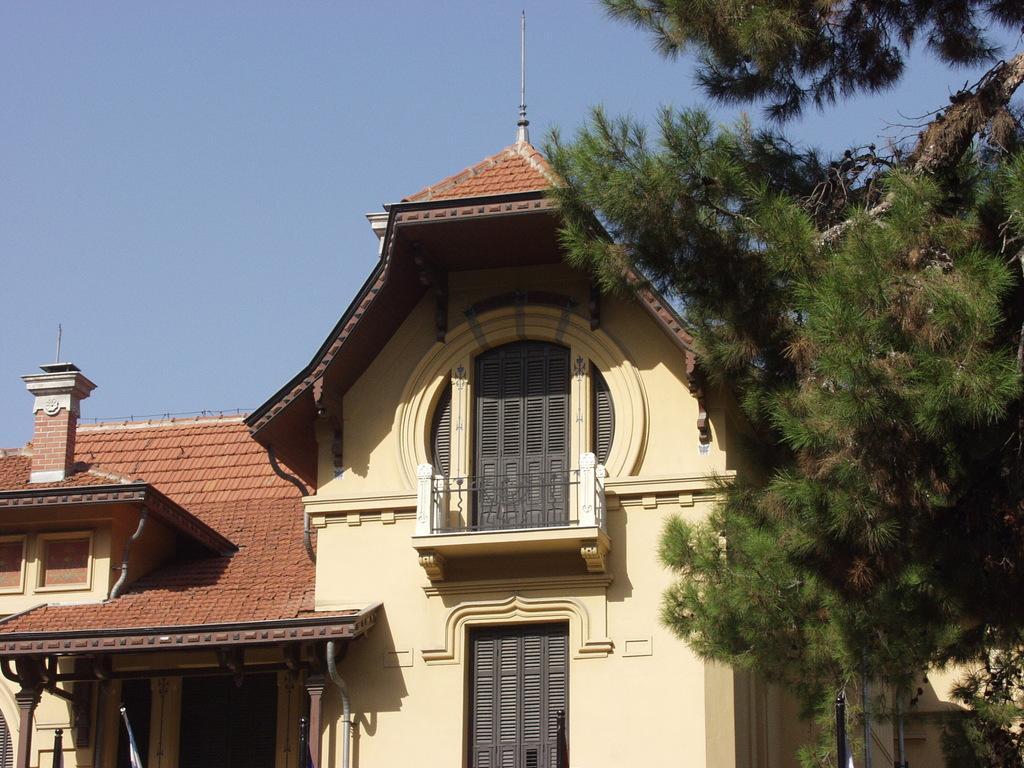Can you describe this image briefly? In the center of the image we can see a building, windows, balcony, roof. In the background of the image we can see a tree, door, wood pillars, wall. At the top of the image we can see the sky. 